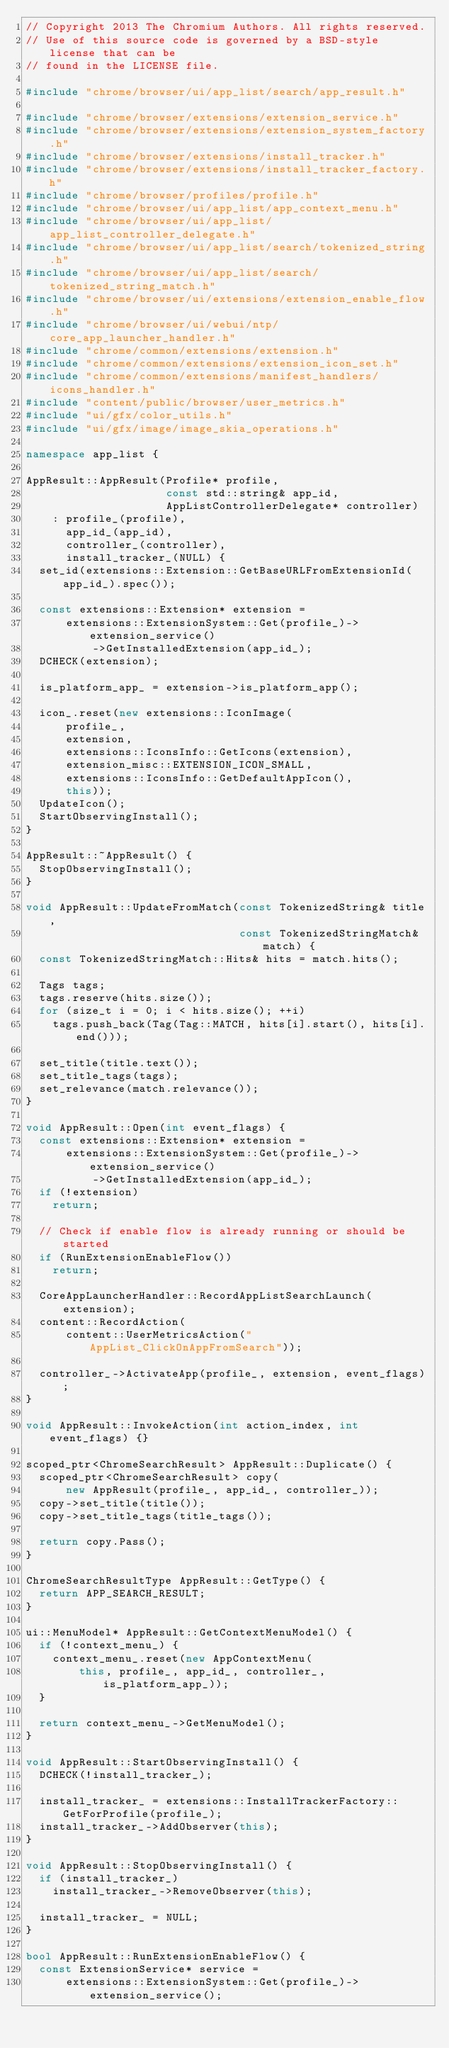<code> <loc_0><loc_0><loc_500><loc_500><_C++_>// Copyright 2013 The Chromium Authors. All rights reserved.
// Use of this source code is governed by a BSD-style license that can be
// found in the LICENSE file.

#include "chrome/browser/ui/app_list/search/app_result.h"

#include "chrome/browser/extensions/extension_service.h"
#include "chrome/browser/extensions/extension_system_factory.h"
#include "chrome/browser/extensions/install_tracker.h"
#include "chrome/browser/extensions/install_tracker_factory.h"
#include "chrome/browser/profiles/profile.h"
#include "chrome/browser/ui/app_list/app_context_menu.h"
#include "chrome/browser/ui/app_list/app_list_controller_delegate.h"
#include "chrome/browser/ui/app_list/search/tokenized_string.h"
#include "chrome/browser/ui/app_list/search/tokenized_string_match.h"
#include "chrome/browser/ui/extensions/extension_enable_flow.h"
#include "chrome/browser/ui/webui/ntp/core_app_launcher_handler.h"
#include "chrome/common/extensions/extension.h"
#include "chrome/common/extensions/extension_icon_set.h"
#include "chrome/common/extensions/manifest_handlers/icons_handler.h"
#include "content/public/browser/user_metrics.h"
#include "ui/gfx/color_utils.h"
#include "ui/gfx/image/image_skia_operations.h"

namespace app_list {

AppResult::AppResult(Profile* profile,
                     const std::string& app_id,
                     AppListControllerDelegate* controller)
    : profile_(profile),
      app_id_(app_id),
      controller_(controller),
      install_tracker_(NULL) {
  set_id(extensions::Extension::GetBaseURLFromExtensionId(app_id_).spec());

  const extensions::Extension* extension =
      extensions::ExtensionSystem::Get(profile_)->extension_service()
          ->GetInstalledExtension(app_id_);
  DCHECK(extension);

  is_platform_app_ = extension->is_platform_app();

  icon_.reset(new extensions::IconImage(
      profile_,
      extension,
      extensions::IconsInfo::GetIcons(extension),
      extension_misc::EXTENSION_ICON_SMALL,
      extensions::IconsInfo::GetDefaultAppIcon(),
      this));
  UpdateIcon();
  StartObservingInstall();
}

AppResult::~AppResult() {
  StopObservingInstall();
}

void AppResult::UpdateFromMatch(const TokenizedString& title,
                                const TokenizedStringMatch& match) {
  const TokenizedStringMatch::Hits& hits = match.hits();

  Tags tags;
  tags.reserve(hits.size());
  for (size_t i = 0; i < hits.size(); ++i)
    tags.push_back(Tag(Tag::MATCH, hits[i].start(), hits[i].end()));

  set_title(title.text());
  set_title_tags(tags);
  set_relevance(match.relevance());
}

void AppResult::Open(int event_flags) {
  const extensions::Extension* extension =
      extensions::ExtensionSystem::Get(profile_)->extension_service()
          ->GetInstalledExtension(app_id_);
  if (!extension)
    return;

  // Check if enable flow is already running or should be started
  if (RunExtensionEnableFlow())
    return;

  CoreAppLauncherHandler::RecordAppListSearchLaunch(extension);
  content::RecordAction(
      content::UserMetricsAction("AppList_ClickOnAppFromSearch"));

  controller_->ActivateApp(profile_, extension, event_flags);
}

void AppResult::InvokeAction(int action_index, int event_flags) {}

scoped_ptr<ChromeSearchResult> AppResult::Duplicate() {
  scoped_ptr<ChromeSearchResult> copy(
      new AppResult(profile_, app_id_, controller_));
  copy->set_title(title());
  copy->set_title_tags(title_tags());

  return copy.Pass();
}

ChromeSearchResultType AppResult::GetType() {
  return APP_SEARCH_RESULT;
}

ui::MenuModel* AppResult::GetContextMenuModel() {
  if (!context_menu_) {
    context_menu_.reset(new AppContextMenu(
        this, profile_, app_id_, controller_, is_platform_app_));
  }

  return context_menu_->GetMenuModel();
}

void AppResult::StartObservingInstall() {
  DCHECK(!install_tracker_);

  install_tracker_ = extensions::InstallTrackerFactory::GetForProfile(profile_);
  install_tracker_->AddObserver(this);
}

void AppResult::StopObservingInstall() {
  if (install_tracker_)
    install_tracker_->RemoveObserver(this);

  install_tracker_ = NULL;
}

bool AppResult::RunExtensionEnableFlow() {
  const ExtensionService* service =
      extensions::ExtensionSystem::Get(profile_)->extension_service();</code> 